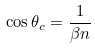<formula> <loc_0><loc_0><loc_500><loc_500>\cos \theta _ { c } = \frac { 1 } { \beta n }</formula> 